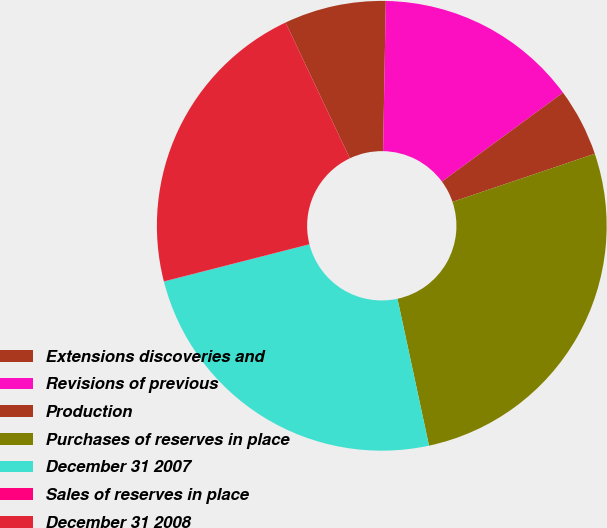Convert chart to OTSL. <chart><loc_0><loc_0><loc_500><loc_500><pie_chart><fcel>Extensions discoveries and<fcel>Revisions of previous<fcel>Production<fcel>Purchases of reserves in place<fcel>December 31 2007<fcel>Sales of reserves in place<fcel>December 31 2008<nl><fcel>7.32%<fcel>14.63%<fcel>4.89%<fcel>26.82%<fcel>24.38%<fcel>0.01%<fcel>21.94%<nl></chart> 